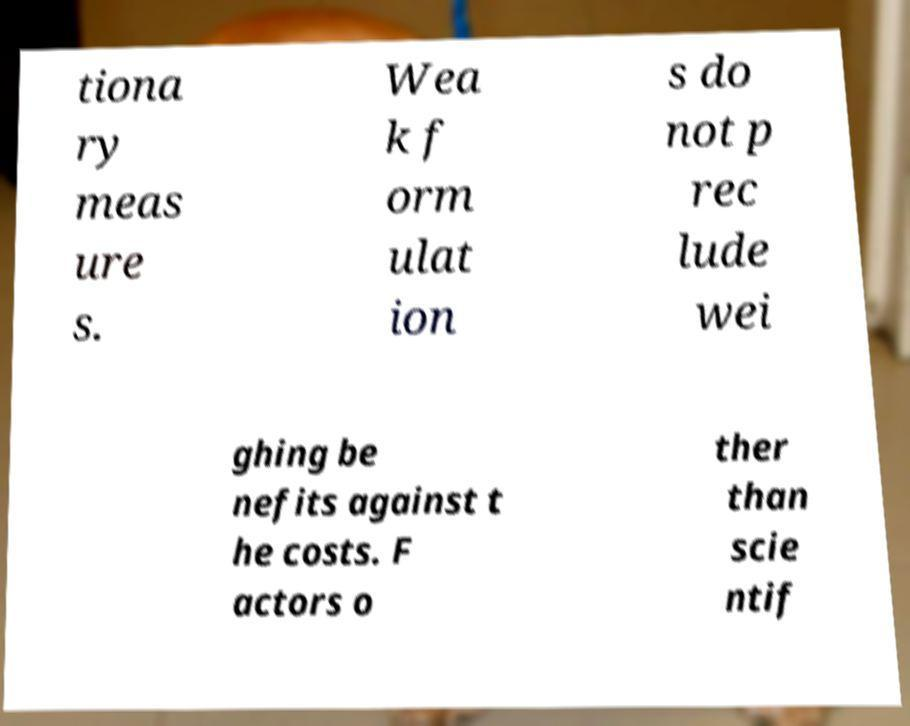For documentation purposes, I need the text within this image transcribed. Could you provide that? tiona ry meas ure s. Wea k f orm ulat ion s do not p rec lude wei ghing be nefits against t he costs. F actors o ther than scie ntif 